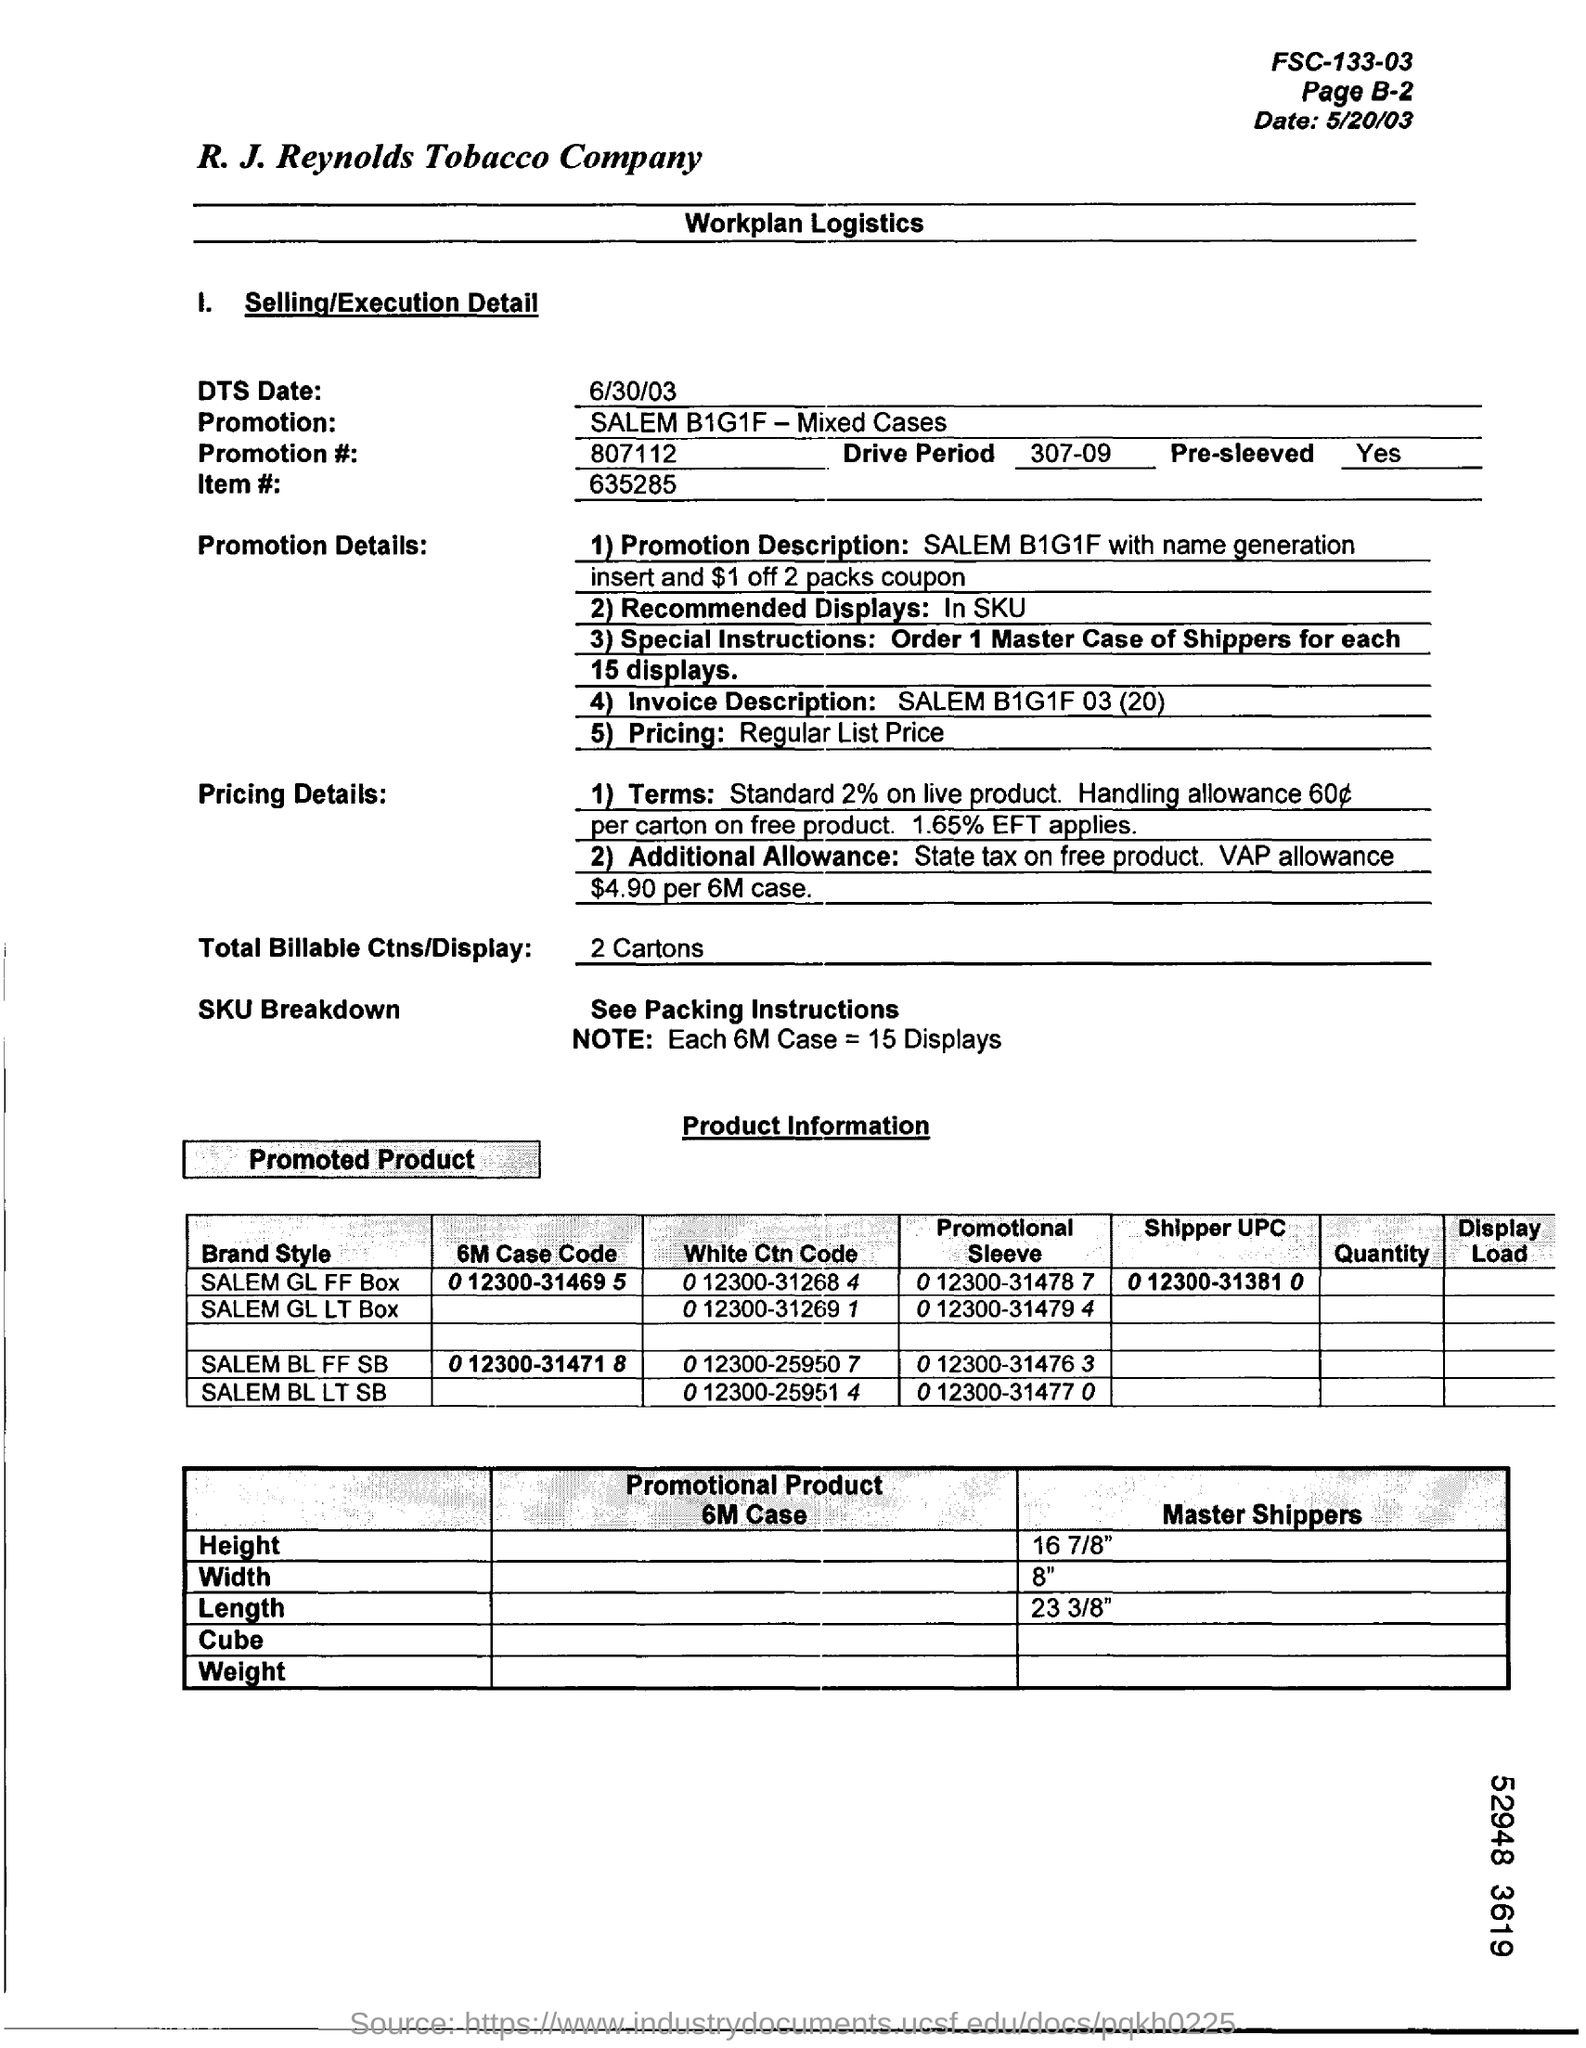Draw attention to some important aspects in this diagram. The DTS (Data Transfer System) date is June 30, 2003. The total number of billable transactions per display is 2 cartons. 